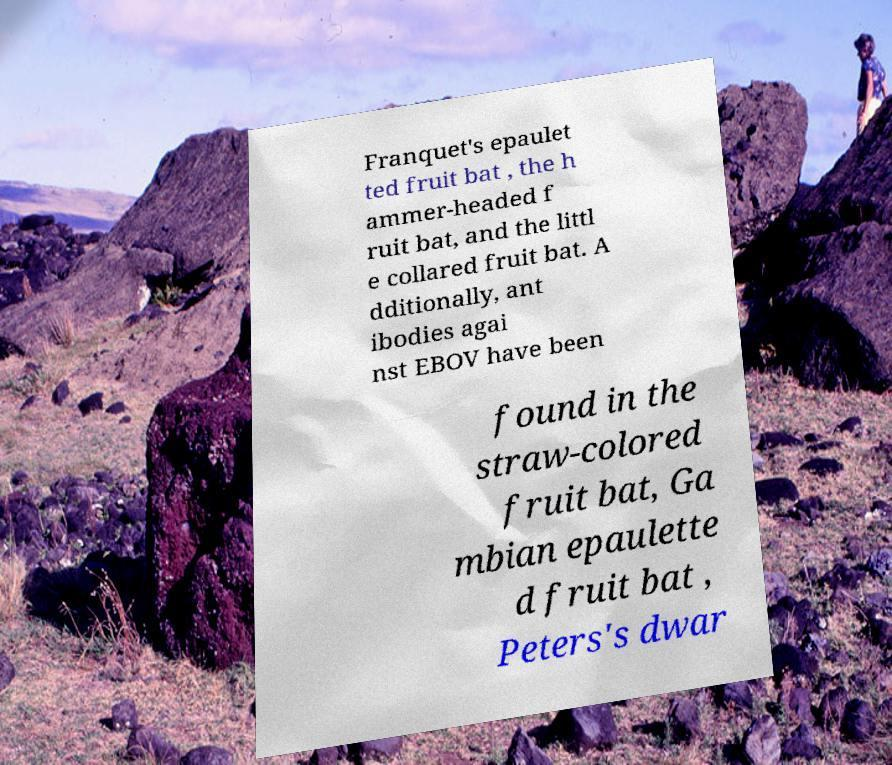Can you read and provide the text displayed in the image?This photo seems to have some interesting text. Can you extract and type it out for me? Franquet's epaulet ted fruit bat , the h ammer-headed f ruit bat, and the littl e collared fruit bat. A dditionally, ant ibodies agai nst EBOV have been found in the straw-colored fruit bat, Ga mbian epaulette d fruit bat , Peters's dwar 